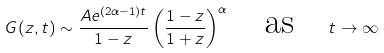Convert formula to latex. <formula><loc_0><loc_0><loc_500><loc_500>G ( z , t ) \sim \frac { A e ^ { ( 2 \alpha - 1 ) t } } { 1 - z } \left ( \frac { 1 - z } { 1 + z } \right ) ^ { \alpha } \quad \text {as} \quad t \rightarrow \infty</formula> 